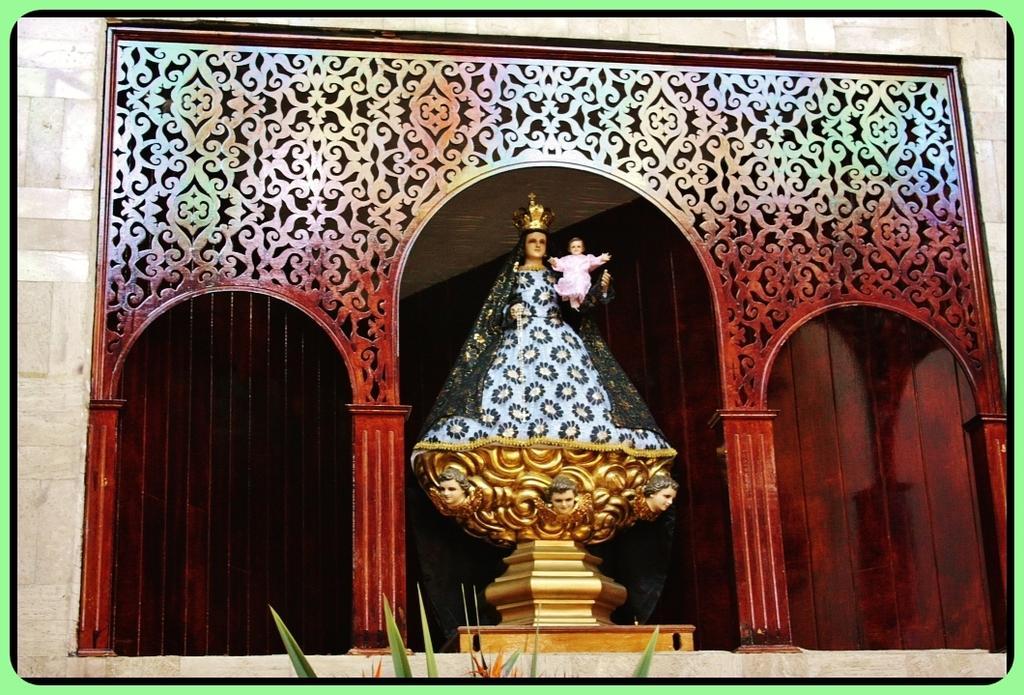Could you give a brief overview of what you see in this image? In the foreground of this image, there is a sculpture in the middle and a red wall in the background. On bottom of the image, there are plants. 